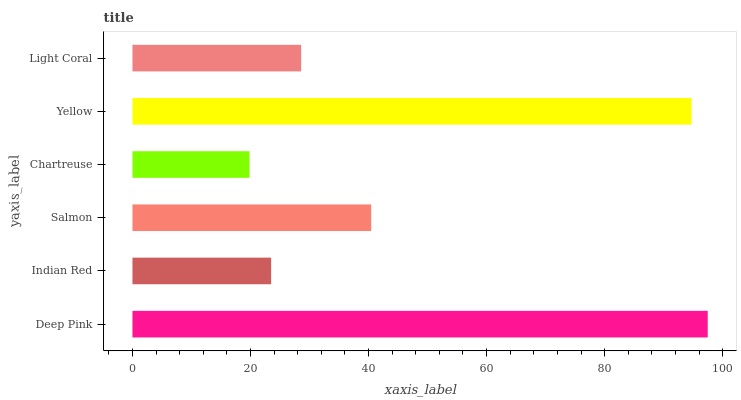Is Chartreuse the minimum?
Answer yes or no. Yes. Is Deep Pink the maximum?
Answer yes or no. Yes. Is Indian Red the minimum?
Answer yes or no. No. Is Indian Red the maximum?
Answer yes or no. No. Is Deep Pink greater than Indian Red?
Answer yes or no. Yes. Is Indian Red less than Deep Pink?
Answer yes or no. Yes. Is Indian Red greater than Deep Pink?
Answer yes or no. No. Is Deep Pink less than Indian Red?
Answer yes or no. No. Is Salmon the high median?
Answer yes or no. Yes. Is Light Coral the low median?
Answer yes or no. Yes. Is Light Coral the high median?
Answer yes or no. No. Is Yellow the low median?
Answer yes or no. No. 